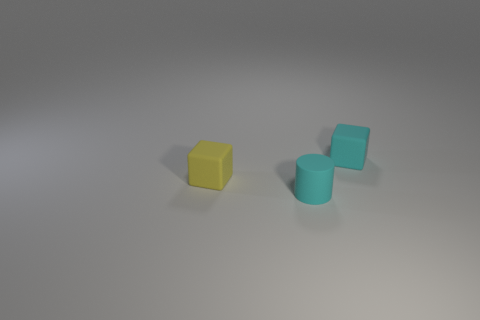The yellow matte object has what shape?
Your answer should be very brief. Cube. Are there more tiny objects that are behind the tiny cyan matte block than large cyan matte cylinders?
Keep it short and to the point. No. Is there any other thing that is the same shape as the small yellow object?
Offer a terse response. Yes. There is another thing that is the same shape as the tiny yellow matte thing; what color is it?
Offer a terse response. Cyan. There is a object that is behind the small yellow thing; what shape is it?
Your answer should be very brief. Cube. Are there any cyan cubes to the left of the small cyan matte cube?
Your response must be concise. No. Is there anything else that has the same size as the cyan block?
Your answer should be very brief. Yes. What color is the other cube that is made of the same material as the small yellow cube?
Give a very brief answer. Cyan. Is the color of the rubber cube on the left side of the cyan matte cylinder the same as the object that is to the right of the tiny cyan cylinder?
Make the answer very short. No. How many cylinders are either tiny things or small yellow things?
Offer a terse response. 1. 